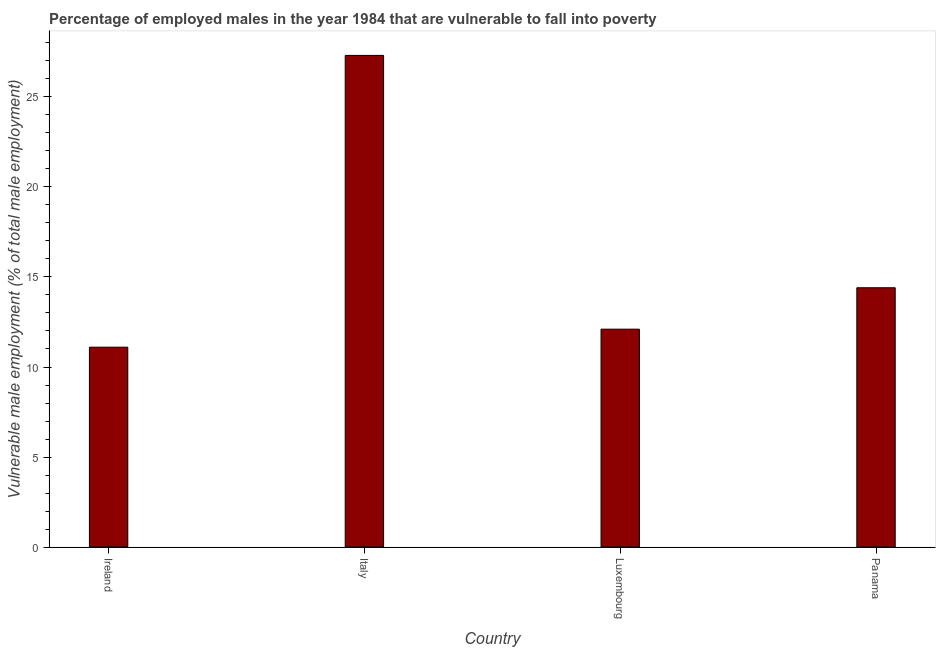Does the graph contain any zero values?
Make the answer very short. No. What is the title of the graph?
Provide a succinct answer. Percentage of employed males in the year 1984 that are vulnerable to fall into poverty. What is the label or title of the Y-axis?
Ensure brevity in your answer.  Vulnerable male employment (% of total male employment). What is the percentage of employed males who are vulnerable to fall into poverty in Luxembourg?
Give a very brief answer. 12.1. Across all countries, what is the maximum percentage of employed males who are vulnerable to fall into poverty?
Provide a succinct answer. 27.3. Across all countries, what is the minimum percentage of employed males who are vulnerable to fall into poverty?
Offer a terse response. 11.1. In which country was the percentage of employed males who are vulnerable to fall into poverty minimum?
Make the answer very short. Ireland. What is the sum of the percentage of employed males who are vulnerable to fall into poverty?
Your answer should be compact. 64.9. What is the average percentage of employed males who are vulnerable to fall into poverty per country?
Keep it short and to the point. 16.23. What is the median percentage of employed males who are vulnerable to fall into poverty?
Provide a succinct answer. 13.25. In how many countries, is the percentage of employed males who are vulnerable to fall into poverty greater than 7 %?
Your answer should be compact. 4. What is the ratio of the percentage of employed males who are vulnerable to fall into poverty in Ireland to that in Luxembourg?
Ensure brevity in your answer.  0.92. Is the percentage of employed males who are vulnerable to fall into poverty in Ireland less than that in Luxembourg?
Provide a short and direct response. Yes. What is the difference between the highest and the second highest percentage of employed males who are vulnerable to fall into poverty?
Offer a very short reply. 12.9. In how many countries, is the percentage of employed males who are vulnerable to fall into poverty greater than the average percentage of employed males who are vulnerable to fall into poverty taken over all countries?
Keep it short and to the point. 1. How many bars are there?
Make the answer very short. 4. How many countries are there in the graph?
Offer a very short reply. 4. What is the Vulnerable male employment (% of total male employment) in Ireland?
Your answer should be very brief. 11.1. What is the Vulnerable male employment (% of total male employment) in Italy?
Make the answer very short. 27.3. What is the Vulnerable male employment (% of total male employment) of Luxembourg?
Ensure brevity in your answer.  12.1. What is the Vulnerable male employment (% of total male employment) of Panama?
Your answer should be compact. 14.4. What is the difference between the Vulnerable male employment (% of total male employment) in Ireland and Italy?
Ensure brevity in your answer.  -16.2. What is the difference between the Vulnerable male employment (% of total male employment) in Ireland and Luxembourg?
Your answer should be very brief. -1. What is the difference between the Vulnerable male employment (% of total male employment) in Ireland and Panama?
Your response must be concise. -3.3. What is the difference between the Vulnerable male employment (% of total male employment) in Italy and Luxembourg?
Provide a succinct answer. 15.2. What is the ratio of the Vulnerable male employment (% of total male employment) in Ireland to that in Italy?
Give a very brief answer. 0.41. What is the ratio of the Vulnerable male employment (% of total male employment) in Ireland to that in Luxembourg?
Your answer should be compact. 0.92. What is the ratio of the Vulnerable male employment (% of total male employment) in Ireland to that in Panama?
Your answer should be compact. 0.77. What is the ratio of the Vulnerable male employment (% of total male employment) in Italy to that in Luxembourg?
Keep it short and to the point. 2.26. What is the ratio of the Vulnerable male employment (% of total male employment) in Italy to that in Panama?
Your response must be concise. 1.9. What is the ratio of the Vulnerable male employment (% of total male employment) in Luxembourg to that in Panama?
Your answer should be compact. 0.84. 